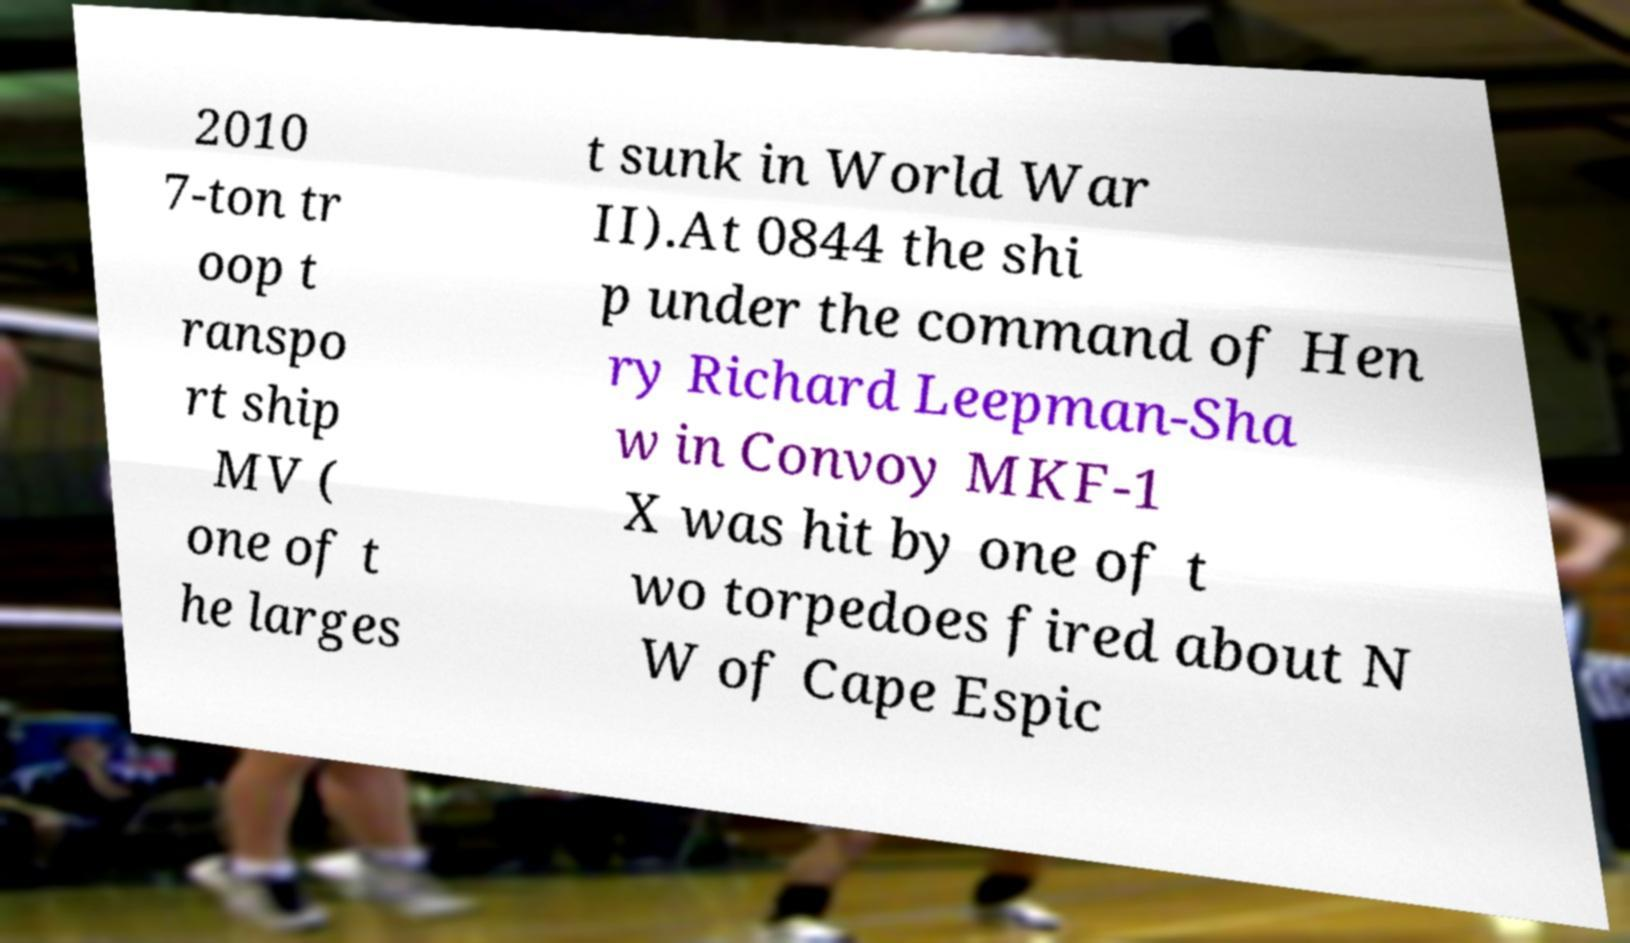Please identify and transcribe the text found in this image. 2010 7-ton tr oop t ranspo rt ship MV ( one of t he larges t sunk in World War II).At 0844 the shi p under the command of Hen ry Richard Leepman-Sha w in Convoy MKF-1 X was hit by one of t wo torpedoes fired about N W of Cape Espic 